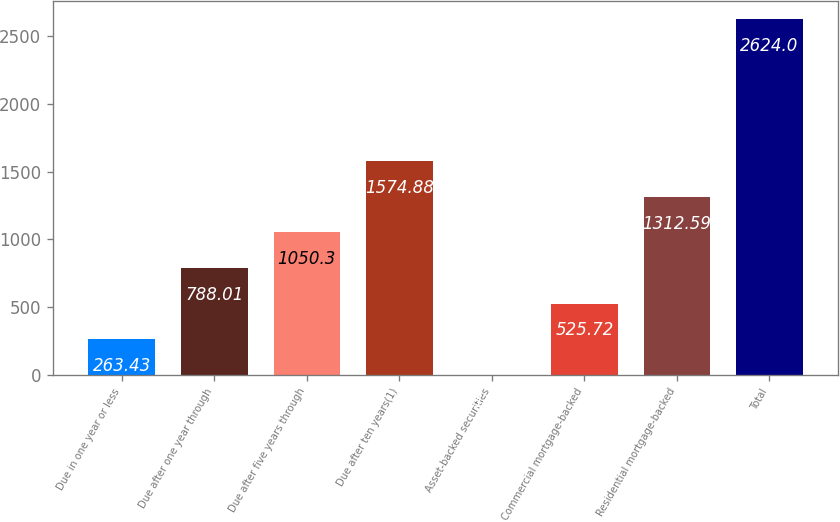Convert chart to OTSL. <chart><loc_0><loc_0><loc_500><loc_500><bar_chart><fcel>Due in one year or less<fcel>Due after one year through<fcel>Due after five years through<fcel>Due after ten years(1)<fcel>Asset-backed securities<fcel>Commercial mortgage-backed<fcel>Residential mortgage-backed<fcel>Total<nl><fcel>263.43<fcel>788.01<fcel>1050.3<fcel>1574.88<fcel>1.14<fcel>525.72<fcel>1312.59<fcel>2624<nl></chart> 